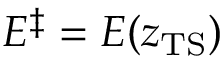Convert formula to latex. <formula><loc_0><loc_0><loc_500><loc_500>E ^ { \ddagger } = E ( z _ { T S } )</formula> 